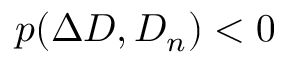Convert formula to latex. <formula><loc_0><loc_0><loc_500><loc_500>p ( \Delta D , D _ { n } ) < 0</formula> 